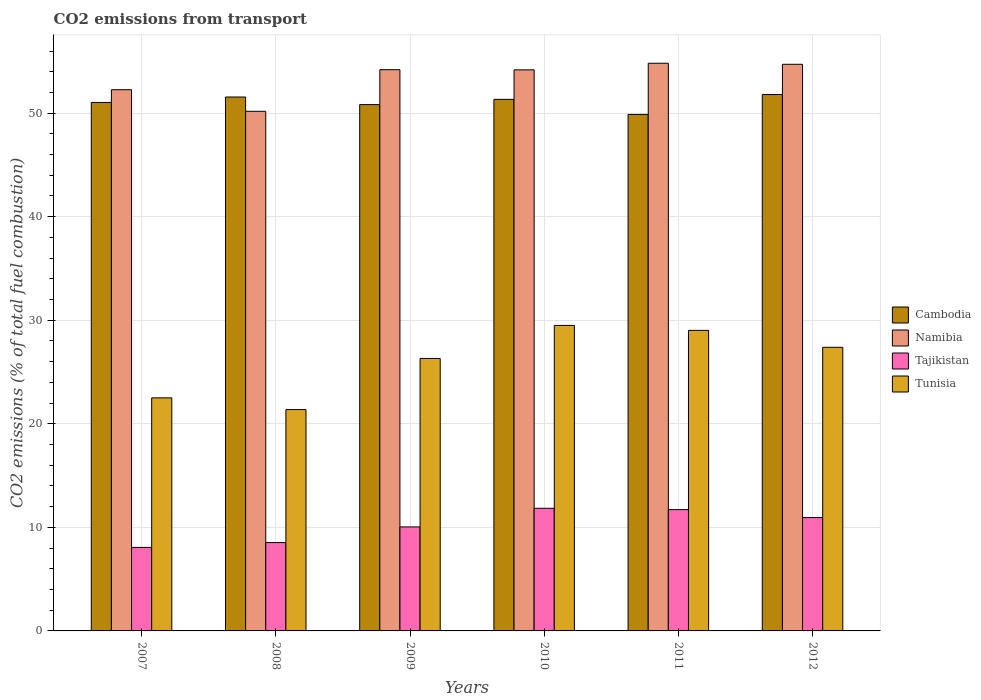How many bars are there on the 1st tick from the right?
Ensure brevity in your answer.  4. What is the label of the 4th group of bars from the left?
Offer a terse response. 2010. In how many cases, is the number of bars for a given year not equal to the number of legend labels?
Make the answer very short. 0. What is the total CO2 emitted in Tajikistan in 2007?
Offer a very short reply. 8.06. Across all years, what is the maximum total CO2 emitted in Tajikistan?
Provide a succinct answer. 11.84. Across all years, what is the minimum total CO2 emitted in Namibia?
Offer a very short reply. 50.18. In which year was the total CO2 emitted in Tunisia maximum?
Make the answer very short. 2010. In which year was the total CO2 emitted in Cambodia minimum?
Offer a very short reply. 2011. What is the total total CO2 emitted in Namibia in the graph?
Your answer should be compact. 320.35. What is the difference between the total CO2 emitted in Tajikistan in 2007 and that in 2012?
Provide a short and direct response. -2.88. What is the difference between the total CO2 emitted in Tajikistan in 2007 and the total CO2 emitted in Namibia in 2010?
Your answer should be very brief. -46.12. What is the average total CO2 emitted in Namibia per year?
Keep it short and to the point. 53.39. In the year 2012, what is the difference between the total CO2 emitted in Tunisia and total CO2 emitted in Cambodia?
Keep it short and to the point. -24.41. What is the ratio of the total CO2 emitted in Cambodia in 2007 to that in 2012?
Provide a succinct answer. 0.99. Is the total CO2 emitted in Namibia in 2007 less than that in 2008?
Your response must be concise. No. What is the difference between the highest and the second highest total CO2 emitted in Tajikistan?
Ensure brevity in your answer.  0.13. What is the difference between the highest and the lowest total CO2 emitted in Namibia?
Give a very brief answer. 4.64. In how many years, is the total CO2 emitted in Cambodia greater than the average total CO2 emitted in Cambodia taken over all years?
Your answer should be very brief. 3. Is the sum of the total CO2 emitted in Tunisia in 2009 and 2012 greater than the maximum total CO2 emitted in Namibia across all years?
Provide a short and direct response. No. Is it the case that in every year, the sum of the total CO2 emitted in Tunisia and total CO2 emitted in Cambodia is greater than the sum of total CO2 emitted in Namibia and total CO2 emitted in Tajikistan?
Offer a very short reply. No. What does the 2nd bar from the left in 2007 represents?
Your answer should be compact. Namibia. What does the 1st bar from the right in 2011 represents?
Your answer should be compact. Tunisia. How many bars are there?
Provide a succinct answer. 24. Are all the bars in the graph horizontal?
Provide a short and direct response. No. What is the difference between two consecutive major ticks on the Y-axis?
Make the answer very short. 10. Does the graph contain any zero values?
Your response must be concise. No. Does the graph contain grids?
Your response must be concise. Yes. Where does the legend appear in the graph?
Your answer should be compact. Center right. How many legend labels are there?
Your response must be concise. 4. How are the legend labels stacked?
Ensure brevity in your answer.  Vertical. What is the title of the graph?
Offer a very short reply. CO2 emissions from transport. Does "Togo" appear as one of the legend labels in the graph?
Your answer should be very brief. No. What is the label or title of the Y-axis?
Your answer should be compact. CO2 emissions (% of total fuel combustion). What is the CO2 emissions (% of total fuel combustion) in Cambodia in 2007?
Make the answer very short. 51.03. What is the CO2 emissions (% of total fuel combustion) of Namibia in 2007?
Provide a succinct answer. 52.26. What is the CO2 emissions (% of total fuel combustion) of Tajikistan in 2007?
Your answer should be compact. 8.06. What is the CO2 emissions (% of total fuel combustion) of Tunisia in 2007?
Keep it short and to the point. 22.51. What is the CO2 emissions (% of total fuel combustion) of Cambodia in 2008?
Give a very brief answer. 51.56. What is the CO2 emissions (% of total fuel combustion) of Namibia in 2008?
Make the answer very short. 50.18. What is the CO2 emissions (% of total fuel combustion) of Tajikistan in 2008?
Provide a short and direct response. 8.53. What is the CO2 emissions (% of total fuel combustion) of Tunisia in 2008?
Your response must be concise. 21.38. What is the CO2 emissions (% of total fuel combustion) in Cambodia in 2009?
Keep it short and to the point. 50.82. What is the CO2 emissions (% of total fuel combustion) of Namibia in 2009?
Your response must be concise. 54.2. What is the CO2 emissions (% of total fuel combustion) in Tajikistan in 2009?
Provide a succinct answer. 10.04. What is the CO2 emissions (% of total fuel combustion) of Tunisia in 2009?
Provide a succinct answer. 26.31. What is the CO2 emissions (% of total fuel combustion) of Cambodia in 2010?
Your response must be concise. 51.33. What is the CO2 emissions (% of total fuel combustion) of Namibia in 2010?
Provide a short and direct response. 54.18. What is the CO2 emissions (% of total fuel combustion) of Tajikistan in 2010?
Keep it short and to the point. 11.84. What is the CO2 emissions (% of total fuel combustion) in Tunisia in 2010?
Your answer should be compact. 29.5. What is the CO2 emissions (% of total fuel combustion) of Cambodia in 2011?
Your answer should be very brief. 49.88. What is the CO2 emissions (% of total fuel combustion) of Namibia in 2011?
Your answer should be compact. 54.82. What is the CO2 emissions (% of total fuel combustion) of Tajikistan in 2011?
Your answer should be very brief. 11.72. What is the CO2 emissions (% of total fuel combustion) of Tunisia in 2011?
Your answer should be compact. 29.02. What is the CO2 emissions (% of total fuel combustion) in Cambodia in 2012?
Offer a terse response. 51.8. What is the CO2 emissions (% of total fuel combustion) of Namibia in 2012?
Offer a very short reply. 54.72. What is the CO2 emissions (% of total fuel combustion) in Tajikistan in 2012?
Provide a short and direct response. 10.95. What is the CO2 emissions (% of total fuel combustion) in Tunisia in 2012?
Your answer should be very brief. 27.39. Across all years, what is the maximum CO2 emissions (% of total fuel combustion) in Cambodia?
Your answer should be compact. 51.8. Across all years, what is the maximum CO2 emissions (% of total fuel combustion) of Namibia?
Offer a terse response. 54.82. Across all years, what is the maximum CO2 emissions (% of total fuel combustion) of Tajikistan?
Offer a very short reply. 11.84. Across all years, what is the maximum CO2 emissions (% of total fuel combustion) of Tunisia?
Offer a terse response. 29.5. Across all years, what is the minimum CO2 emissions (% of total fuel combustion) in Cambodia?
Make the answer very short. 49.88. Across all years, what is the minimum CO2 emissions (% of total fuel combustion) of Namibia?
Your answer should be very brief. 50.18. Across all years, what is the minimum CO2 emissions (% of total fuel combustion) of Tajikistan?
Ensure brevity in your answer.  8.06. Across all years, what is the minimum CO2 emissions (% of total fuel combustion) in Tunisia?
Make the answer very short. 21.38. What is the total CO2 emissions (% of total fuel combustion) in Cambodia in the graph?
Make the answer very short. 306.42. What is the total CO2 emissions (% of total fuel combustion) in Namibia in the graph?
Your answer should be compact. 320.35. What is the total CO2 emissions (% of total fuel combustion) in Tajikistan in the graph?
Keep it short and to the point. 61.15. What is the total CO2 emissions (% of total fuel combustion) of Tunisia in the graph?
Keep it short and to the point. 156.1. What is the difference between the CO2 emissions (% of total fuel combustion) of Cambodia in 2007 and that in 2008?
Keep it short and to the point. -0.53. What is the difference between the CO2 emissions (% of total fuel combustion) of Namibia in 2007 and that in 2008?
Make the answer very short. 2.08. What is the difference between the CO2 emissions (% of total fuel combustion) in Tajikistan in 2007 and that in 2008?
Provide a short and direct response. -0.47. What is the difference between the CO2 emissions (% of total fuel combustion) of Tunisia in 2007 and that in 2008?
Your answer should be very brief. 1.13. What is the difference between the CO2 emissions (% of total fuel combustion) of Cambodia in 2007 and that in 2009?
Give a very brief answer. 0.21. What is the difference between the CO2 emissions (% of total fuel combustion) of Namibia in 2007 and that in 2009?
Provide a short and direct response. -1.93. What is the difference between the CO2 emissions (% of total fuel combustion) in Tajikistan in 2007 and that in 2009?
Your response must be concise. -1.98. What is the difference between the CO2 emissions (% of total fuel combustion) in Tunisia in 2007 and that in 2009?
Offer a very short reply. -3.81. What is the difference between the CO2 emissions (% of total fuel combustion) of Cambodia in 2007 and that in 2010?
Make the answer very short. -0.3. What is the difference between the CO2 emissions (% of total fuel combustion) in Namibia in 2007 and that in 2010?
Provide a succinct answer. -1.92. What is the difference between the CO2 emissions (% of total fuel combustion) in Tajikistan in 2007 and that in 2010?
Provide a short and direct response. -3.78. What is the difference between the CO2 emissions (% of total fuel combustion) in Tunisia in 2007 and that in 2010?
Provide a short and direct response. -7. What is the difference between the CO2 emissions (% of total fuel combustion) of Cambodia in 2007 and that in 2011?
Offer a terse response. 1.16. What is the difference between the CO2 emissions (% of total fuel combustion) in Namibia in 2007 and that in 2011?
Your response must be concise. -2.55. What is the difference between the CO2 emissions (% of total fuel combustion) of Tajikistan in 2007 and that in 2011?
Provide a short and direct response. -3.65. What is the difference between the CO2 emissions (% of total fuel combustion) of Tunisia in 2007 and that in 2011?
Your answer should be very brief. -6.52. What is the difference between the CO2 emissions (% of total fuel combustion) of Cambodia in 2007 and that in 2012?
Ensure brevity in your answer.  -0.77. What is the difference between the CO2 emissions (% of total fuel combustion) of Namibia in 2007 and that in 2012?
Make the answer very short. -2.45. What is the difference between the CO2 emissions (% of total fuel combustion) in Tajikistan in 2007 and that in 2012?
Keep it short and to the point. -2.88. What is the difference between the CO2 emissions (% of total fuel combustion) in Tunisia in 2007 and that in 2012?
Your response must be concise. -4.88. What is the difference between the CO2 emissions (% of total fuel combustion) of Cambodia in 2008 and that in 2009?
Your answer should be very brief. 0.73. What is the difference between the CO2 emissions (% of total fuel combustion) in Namibia in 2008 and that in 2009?
Offer a terse response. -4.02. What is the difference between the CO2 emissions (% of total fuel combustion) in Tajikistan in 2008 and that in 2009?
Offer a very short reply. -1.51. What is the difference between the CO2 emissions (% of total fuel combustion) of Tunisia in 2008 and that in 2009?
Keep it short and to the point. -4.94. What is the difference between the CO2 emissions (% of total fuel combustion) in Cambodia in 2008 and that in 2010?
Provide a succinct answer. 0.23. What is the difference between the CO2 emissions (% of total fuel combustion) of Namibia in 2008 and that in 2010?
Your response must be concise. -4. What is the difference between the CO2 emissions (% of total fuel combustion) in Tajikistan in 2008 and that in 2010?
Provide a short and direct response. -3.31. What is the difference between the CO2 emissions (% of total fuel combustion) in Tunisia in 2008 and that in 2010?
Keep it short and to the point. -8.13. What is the difference between the CO2 emissions (% of total fuel combustion) of Cambodia in 2008 and that in 2011?
Your answer should be very brief. 1.68. What is the difference between the CO2 emissions (% of total fuel combustion) of Namibia in 2008 and that in 2011?
Your response must be concise. -4.64. What is the difference between the CO2 emissions (% of total fuel combustion) in Tajikistan in 2008 and that in 2011?
Ensure brevity in your answer.  -3.18. What is the difference between the CO2 emissions (% of total fuel combustion) in Tunisia in 2008 and that in 2011?
Your answer should be very brief. -7.65. What is the difference between the CO2 emissions (% of total fuel combustion) in Cambodia in 2008 and that in 2012?
Provide a succinct answer. -0.24. What is the difference between the CO2 emissions (% of total fuel combustion) of Namibia in 2008 and that in 2012?
Provide a short and direct response. -4.54. What is the difference between the CO2 emissions (% of total fuel combustion) of Tajikistan in 2008 and that in 2012?
Keep it short and to the point. -2.42. What is the difference between the CO2 emissions (% of total fuel combustion) in Tunisia in 2008 and that in 2012?
Offer a very short reply. -6.01. What is the difference between the CO2 emissions (% of total fuel combustion) of Cambodia in 2009 and that in 2010?
Give a very brief answer. -0.51. What is the difference between the CO2 emissions (% of total fuel combustion) of Namibia in 2009 and that in 2010?
Offer a very short reply. 0.02. What is the difference between the CO2 emissions (% of total fuel combustion) in Tajikistan in 2009 and that in 2010?
Give a very brief answer. -1.8. What is the difference between the CO2 emissions (% of total fuel combustion) in Tunisia in 2009 and that in 2010?
Your answer should be very brief. -3.19. What is the difference between the CO2 emissions (% of total fuel combustion) of Cambodia in 2009 and that in 2011?
Give a very brief answer. 0.95. What is the difference between the CO2 emissions (% of total fuel combustion) in Namibia in 2009 and that in 2011?
Provide a succinct answer. -0.62. What is the difference between the CO2 emissions (% of total fuel combustion) of Tajikistan in 2009 and that in 2011?
Provide a succinct answer. -1.67. What is the difference between the CO2 emissions (% of total fuel combustion) of Tunisia in 2009 and that in 2011?
Provide a succinct answer. -2.71. What is the difference between the CO2 emissions (% of total fuel combustion) in Cambodia in 2009 and that in 2012?
Provide a short and direct response. -0.97. What is the difference between the CO2 emissions (% of total fuel combustion) in Namibia in 2009 and that in 2012?
Give a very brief answer. -0.52. What is the difference between the CO2 emissions (% of total fuel combustion) in Tajikistan in 2009 and that in 2012?
Ensure brevity in your answer.  -0.91. What is the difference between the CO2 emissions (% of total fuel combustion) of Tunisia in 2009 and that in 2012?
Ensure brevity in your answer.  -1.07. What is the difference between the CO2 emissions (% of total fuel combustion) in Cambodia in 2010 and that in 2011?
Provide a succinct answer. 1.45. What is the difference between the CO2 emissions (% of total fuel combustion) of Namibia in 2010 and that in 2011?
Offer a terse response. -0.64. What is the difference between the CO2 emissions (% of total fuel combustion) in Tajikistan in 2010 and that in 2011?
Provide a short and direct response. 0.13. What is the difference between the CO2 emissions (% of total fuel combustion) in Tunisia in 2010 and that in 2011?
Your answer should be compact. 0.48. What is the difference between the CO2 emissions (% of total fuel combustion) in Cambodia in 2010 and that in 2012?
Your response must be concise. -0.47. What is the difference between the CO2 emissions (% of total fuel combustion) of Namibia in 2010 and that in 2012?
Provide a succinct answer. -0.54. What is the difference between the CO2 emissions (% of total fuel combustion) in Tajikistan in 2010 and that in 2012?
Keep it short and to the point. 0.89. What is the difference between the CO2 emissions (% of total fuel combustion) of Tunisia in 2010 and that in 2012?
Your answer should be very brief. 2.11. What is the difference between the CO2 emissions (% of total fuel combustion) of Cambodia in 2011 and that in 2012?
Your response must be concise. -1.92. What is the difference between the CO2 emissions (% of total fuel combustion) of Namibia in 2011 and that in 2012?
Offer a terse response. 0.1. What is the difference between the CO2 emissions (% of total fuel combustion) of Tajikistan in 2011 and that in 2012?
Make the answer very short. 0.77. What is the difference between the CO2 emissions (% of total fuel combustion) in Tunisia in 2011 and that in 2012?
Offer a terse response. 1.63. What is the difference between the CO2 emissions (% of total fuel combustion) of Cambodia in 2007 and the CO2 emissions (% of total fuel combustion) of Namibia in 2008?
Your response must be concise. 0.85. What is the difference between the CO2 emissions (% of total fuel combustion) of Cambodia in 2007 and the CO2 emissions (% of total fuel combustion) of Tajikistan in 2008?
Make the answer very short. 42.5. What is the difference between the CO2 emissions (% of total fuel combustion) in Cambodia in 2007 and the CO2 emissions (% of total fuel combustion) in Tunisia in 2008?
Ensure brevity in your answer.  29.66. What is the difference between the CO2 emissions (% of total fuel combustion) of Namibia in 2007 and the CO2 emissions (% of total fuel combustion) of Tajikistan in 2008?
Your response must be concise. 43.73. What is the difference between the CO2 emissions (% of total fuel combustion) in Namibia in 2007 and the CO2 emissions (% of total fuel combustion) in Tunisia in 2008?
Your answer should be very brief. 30.89. What is the difference between the CO2 emissions (% of total fuel combustion) of Tajikistan in 2007 and the CO2 emissions (% of total fuel combustion) of Tunisia in 2008?
Offer a very short reply. -13.31. What is the difference between the CO2 emissions (% of total fuel combustion) of Cambodia in 2007 and the CO2 emissions (% of total fuel combustion) of Namibia in 2009?
Your answer should be compact. -3.16. What is the difference between the CO2 emissions (% of total fuel combustion) in Cambodia in 2007 and the CO2 emissions (% of total fuel combustion) in Tajikistan in 2009?
Provide a short and direct response. 40.99. What is the difference between the CO2 emissions (% of total fuel combustion) in Cambodia in 2007 and the CO2 emissions (% of total fuel combustion) in Tunisia in 2009?
Offer a very short reply. 24.72. What is the difference between the CO2 emissions (% of total fuel combustion) in Namibia in 2007 and the CO2 emissions (% of total fuel combustion) in Tajikistan in 2009?
Your answer should be compact. 42.22. What is the difference between the CO2 emissions (% of total fuel combustion) of Namibia in 2007 and the CO2 emissions (% of total fuel combustion) of Tunisia in 2009?
Provide a short and direct response. 25.95. What is the difference between the CO2 emissions (% of total fuel combustion) of Tajikistan in 2007 and the CO2 emissions (% of total fuel combustion) of Tunisia in 2009?
Provide a succinct answer. -18.25. What is the difference between the CO2 emissions (% of total fuel combustion) in Cambodia in 2007 and the CO2 emissions (% of total fuel combustion) in Namibia in 2010?
Offer a terse response. -3.15. What is the difference between the CO2 emissions (% of total fuel combustion) in Cambodia in 2007 and the CO2 emissions (% of total fuel combustion) in Tajikistan in 2010?
Keep it short and to the point. 39.19. What is the difference between the CO2 emissions (% of total fuel combustion) in Cambodia in 2007 and the CO2 emissions (% of total fuel combustion) in Tunisia in 2010?
Give a very brief answer. 21.53. What is the difference between the CO2 emissions (% of total fuel combustion) of Namibia in 2007 and the CO2 emissions (% of total fuel combustion) of Tajikistan in 2010?
Ensure brevity in your answer.  40.42. What is the difference between the CO2 emissions (% of total fuel combustion) of Namibia in 2007 and the CO2 emissions (% of total fuel combustion) of Tunisia in 2010?
Make the answer very short. 22.76. What is the difference between the CO2 emissions (% of total fuel combustion) in Tajikistan in 2007 and the CO2 emissions (% of total fuel combustion) in Tunisia in 2010?
Keep it short and to the point. -21.44. What is the difference between the CO2 emissions (% of total fuel combustion) of Cambodia in 2007 and the CO2 emissions (% of total fuel combustion) of Namibia in 2011?
Provide a short and direct response. -3.78. What is the difference between the CO2 emissions (% of total fuel combustion) in Cambodia in 2007 and the CO2 emissions (% of total fuel combustion) in Tajikistan in 2011?
Keep it short and to the point. 39.32. What is the difference between the CO2 emissions (% of total fuel combustion) in Cambodia in 2007 and the CO2 emissions (% of total fuel combustion) in Tunisia in 2011?
Offer a very short reply. 22.01. What is the difference between the CO2 emissions (% of total fuel combustion) in Namibia in 2007 and the CO2 emissions (% of total fuel combustion) in Tajikistan in 2011?
Ensure brevity in your answer.  40.55. What is the difference between the CO2 emissions (% of total fuel combustion) of Namibia in 2007 and the CO2 emissions (% of total fuel combustion) of Tunisia in 2011?
Provide a short and direct response. 23.24. What is the difference between the CO2 emissions (% of total fuel combustion) in Tajikistan in 2007 and the CO2 emissions (% of total fuel combustion) in Tunisia in 2011?
Ensure brevity in your answer.  -20.96. What is the difference between the CO2 emissions (% of total fuel combustion) in Cambodia in 2007 and the CO2 emissions (% of total fuel combustion) in Namibia in 2012?
Ensure brevity in your answer.  -3.68. What is the difference between the CO2 emissions (% of total fuel combustion) in Cambodia in 2007 and the CO2 emissions (% of total fuel combustion) in Tajikistan in 2012?
Your answer should be very brief. 40.08. What is the difference between the CO2 emissions (% of total fuel combustion) in Cambodia in 2007 and the CO2 emissions (% of total fuel combustion) in Tunisia in 2012?
Your answer should be compact. 23.65. What is the difference between the CO2 emissions (% of total fuel combustion) in Namibia in 2007 and the CO2 emissions (% of total fuel combustion) in Tajikistan in 2012?
Your response must be concise. 41.31. What is the difference between the CO2 emissions (% of total fuel combustion) of Namibia in 2007 and the CO2 emissions (% of total fuel combustion) of Tunisia in 2012?
Give a very brief answer. 24.88. What is the difference between the CO2 emissions (% of total fuel combustion) in Tajikistan in 2007 and the CO2 emissions (% of total fuel combustion) in Tunisia in 2012?
Your response must be concise. -19.32. What is the difference between the CO2 emissions (% of total fuel combustion) of Cambodia in 2008 and the CO2 emissions (% of total fuel combustion) of Namibia in 2009?
Make the answer very short. -2.64. What is the difference between the CO2 emissions (% of total fuel combustion) in Cambodia in 2008 and the CO2 emissions (% of total fuel combustion) in Tajikistan in 2009?
Offer a very short reply. 41.51. What is the difference between the CO2 emissions (% of total fuel combustion) in Cambodia in 2008 and the CO2 emissions (% of total fuel combustion) in Tunisia in 2009?
Your response must be concise. 25.24. What is the difference between the CO2 emissions (% of total fuel combustion) of Namibia in 2008 and the CO2 emissions (% of total fuel combustion) of Tajikistan in 2009?
Offer a very short reply. 40.14. What is the difference between the CO2 emissions (% of total fuel combustion) of Namibia in 2008 and the CO2 emissions (% of total fuel combustion) of Tunisia in 2009?
Ensure brevity in your answer.  23.87. What is the difference between the CO2 emissions (% of total fuel combustion) of Tajikistan in 2008 and the CO2 emissions (% of total fuel combustion) of Tunisia in 2009?
Offer a terse response. -17.78. What is the difference between the CO2 emissions (% of total fuel combustion) of Cambodia in 2008 and the CO2 emissions (% of total fuel combustion) of Namibia in 2010?
Offer a very short reply. -2.62. What is the difference between the CO2 emissions (% of total fuel combustion) in Cambodia in 2008 and the CO2 emissions (% of total fuel combustion) in Tajikistan in 2010?
Your answer should be very brief. 39.72. What is the difference between the CO2 emissions (% of total fuel combustion) of Cambodia in 2008 and the CO2 emissions (% of total fuel combustion) of Tunisia in 2010?
Offer a very short reply. 22.06. What is the difference between the CO2 emissions (% of total fuel combustion) of Namibia in 2008 and the CO2 emissions (% of total fuel combustion) of Tajikistan in 2010?
Your answer should be compact. 38.34. What is the difference between the CO2 emissions (% of total fuel combustion) of Namibia in 2008 and the CO2 emissions (% of total fuel combustion) of Tunisia in 2010?
Provide a succinct answer. 20.68. What is the difference between the CO2 emissions (% of total fuel combustion) of Tajikistan in 2008 and the CO2 emissions (% of total fuel combustion) of Tunisia in 2010?
Your answer should be compact. -20.97. What is the difference between the CO2 emissions (% of total fuel combustion) of Cambodia in 2008 and the CO2 emissions (% of total fuel combustion) of Namibia in 2011?
Give a very brief answer. -3.26. What is the difference between the CO2 emissions (% of total fuel combustion) in Cambodia in 2008 and the CO2 emissions (% of total fuel combustion) in Tajikistan in 2011?
Make the answer very short. 39.84. What is the difference between the CO2 emissions (% of total fuel combustion) of Cambodia in 2008 and the CO2 emissions (% of total fuel combustion) of Tunisia in 2011?
Ensure brevity in your answer.  22.54. What is the difference between the CO2 emissions (% of total fuel combustion) in Namibia in 2008 and the CO2 emissions (% of total fuel combustion) in Tajikistan in 2011?
Your answer should be very brief. 38.46. What is the difference between the CO2 emissions (% of total fuel combustion) of Namibia in 2008 and the CO2 emissions (% of total fuel combustion) of Tunisia in 2011?
Ensure brevity in your answer.  21.16. What is the difference between the CO2 emissions (% of total fuel combustion) in Tajikistan in 2008 and the CO2 emissions (% of total fuel combustion) in Tunisia in 2011?
Provide a succinct answer. -20.49. What is the difference between the CO2 emissions (% of total fuel combustion) in Cambodia in 2008 and the CO2 emissions (% of total fuel combustion) in Namibia in 2012?
Make the answer very short. -3.16. What is the difference between the CO2 emissions (% of total fuel combustion) of Cambodia in 2008 and the CO2 emissions (% of total fuel combustion) of Tajikistan in 2012?
Your response must be concise. 40.61. What is the difference between the CO2 emissions (% of total fuel combustion) of Cambodia in 2008 and the CO2 emissions (% of total fuel combustion) of Tunisia in 2012?
Offer a terse response. 24.17. What is the difference between the CO2 emissions (% of total fuel combustion) of Namibia in 2008 and the CO2 emissions (% of total fuel combustion) of Tajikistan in 2012?
Make the answer very short. 39.23. What is the difference between the CO2 emissions (% of total fuel combustion) of Namibia in 2008 and the CO2 emissions (% of total fuel combustion) of Tunisia in 2012?
Your answer should be very brief. 22.79. What is the difference between the CO2 emissions (% of total fuel combustion) of Tajikistan in 2008 and the CO2 emissions (% of total fuel combustion) of Tunisia in 2012?
Offer a very short reply. -18.85. What is the difference between the CO2 emissions (% of total fuel combustion) in Cambodia in 2009 and the CO2 emissions (% of total fuel combustion) in Namibia in 2010?
Your answer should be very brief. -3.36. What is the difference between the CO2 emissions (% of total fuel combustion) of Cambodia in 2009 and the CO2 emissions (% of total fuel combustion) of Tajikistan in 2010?
Ensure brevity in your answer.  38.98. What is the difference between the CO2 emissions (% of total fuel combustion) in Cambodia in 2009 and the CO2 emissions (% of total fuel combustion) in Tunisia in 2010?
Offer a very short reply. 21.32. What is the difference between the CO2 emissions (% of total fuel combustion) in Namibia in 2009 and the CO2 emissions (% of total fuel combustion) in Tajikistan in 2010?
Offer a very short reply. 42.35. What is the difference between the CO2 emissions (% of total fuel combustion) in Namibia in 2009 and the CO2 emissions (% of total fuel combustion) in Tunisia in 2010?
Ensure brevity in your answer.  24.69. What is the difference between the CO2 emissions (% of total fuel combustion) in Tajikistan in 2009 and the CO2 emissions (% of total fuel combustion) in Tunisia in 2010?
Keep it short and to the point. -19.46. What is the difference between the CO2 emissions (% of total fuel combustion) in Cambodia in 2009 and the CO2 emissions (% of total fuel combustion) in Namibia in 2011?
Provide a short and direct response. -3.99. What is the difference between the CO2 emissions (% of total fuel combustion) in Cambodia in 2009 and the CO2 emissions (% of total fuel combustion) in Tajikistan in 2011?
Make the answer very short. 39.11. What is the difference between the CO2 emissions (% of total fuel combustion) in Cambodia in 2009 and the CO2 emissions (% of total fuel combustion) in Tunisia in 2011?
Provide a short and direct response. 21.8. What is the difference between the CO2 emissions (% of total fuel combustion) in Namibia in 2009 and the CO2 emissions (% of total fuel combustion) in Tajikistan in 2011?
Make the answer very short. 42.48. What is the difference between the CO2 emissions (% of total fuel combustion) of Namibia in 2009 and the CO2 emissions (% of total fuel combustion) of Tunisia in 2011?
Keep it short and to the point. 25.17. What is the difference between the CO2 emissions (% of total fuel combustion) in Tajikistan in 2009 and the CO2 emissions (% of total fuel combustion) in Tunisia in 2011?
Your answer should be very brief. -18.98. What is the difference between the CO2 emissions (% of total fuel combustion) of Cambodia in 2009 and the CO2 emissions (% of total fuel combustion) of Namibia in 2012?
Provide a short and direct response. -3.89. What is the difference between the CO2 emissions (% of total fuel combustion) of Cambodia in 2009 and the CO2 emissions (% of total fuel combustion) of Tajikistan in 2012?
Make the answer very short. 39.88. What is the difference between the CO2 emissions (% of total fuel combustion) of Cambodia in 2009 and the CO2 emissions (% of total fuel combustion) of Tunisia in 2012?
Make the answer very short. 23.44. What is the difference between the CO2 emissions (% of total fuel combustion) in Namibia in 2009 and the CO2 emissions (% of total fuel combustion) in Tajikistan in 2012?
Keep it short and to the point. 43.25. What is the difference between the CO2 emissions (% of total fuel combustion) in Namibia in 2009 and the CO2 emissions (% of total fuel combustion) in Tunisia in 2012?
Offer a terse response. 26.81. What is the difference between the CO2 emissions (% of total fuel combustion) in Tajikistan in 2009 and the CO2 emissions (% of total fuel combustion) in Tunisia in 2012?
Ensure brevity in your answer.  -17.34. What is the difference between the CO2 emissions (% of total fuel combustion) in Cambodia in 2010 and the CO2 emissions (% of total fuel combustion) in Namibia in 2011?
Your response must be concise. -3.49. What is the difference between the CO2 emissions (% of total fuel combustion) in Cambodia in 2010 and the CO2 emissions (% of total fuel combustion) in Tajikistan in 2011?
Offer a very short reply. 39.61. What is the difference between the CO2 emissions (% of total fuel combustion) in Cambodia in 2010 and the CO2 emissions (% of total fuel combustion) in Tunisia in 2011?
Ensure brevity in your answer.  22.31. What is the difference between the CO2 emissions (% of total fuel combustion) of Namibia in 2010 and the CO2 emissions (% of total fuel combustion) of Tajikistan in 2011?
Keep it short and to the point. 42.47. What is the difference between the CO2 emissions (% of total fuel combustion) of Namibia in 2010 and the CO2 emissions (% of total fuel combustion) of Tunisia in 2011?
Provide a succinct answer. 25.16. What is the difference between the CO2 emissions (% of total fuel combustion) in Tajikistan in 2010 and the CO2 emissions (% of total fuel combustion) in Tunisia in 2011?
Make the answer very short. -17.18. What is the difference between the CO2 emissions (% of total fuel combustion) in Cambodia in 2010 and the CO2 emissions (% of total fuel combustion) in Namibia in 2012?
Make the answer very short. -3.39. What is the difference between the CO2 emissions (% of total fuel combustion) in Cambodia in 2010 and the CO2 emissions (% of total fuel combustion) in Tajikistan in 2012?
Make the answer very short. 40.38. What is the difference between the CO2 emissions (% of total fuel combustion) of Cambodia in 2010 and the CO2 emissions (% of total fuel combustion) of Tunisia in 2012?
Provide a succinct answer. 23.94. What is the difference between the CO2 emissions (% of total fuel combustion) of Namibia in 2010 and the CO2 emissions (% of total fuel combustion) of Tajikistan in 2012?
Provide a short and direct response. 43.23. What is the difference between the CO2 emissions (% of total fuel combustion) in Namibia in 2010 and the CO2 emissions (% of total fuel combustion) in Tunisia in 2012?
Give a very brief answer. 26.79. What is the difference between the CO2 emissions (% of total fuel combustion) in Tajikistan in 2010 and the CO2 emissions (% of total fuel combustion) in Tunisia in 2012?
Your answer should be very brief. -15.54. What is the difference between the CO2 emissions (% of total fuel combustion) in Cambodia in 2011 and the CO2 emissions (% of total fuel combustion) in Namibia in 2012?
Your answer should be compact. -4.84. What is the difference between the CO2 emissions (% of total fuel combustion) of Cambodia in 2011 and the CO2 emissions (% of total fuel combustion) of Tajikistan in 2012?
Your answer should be very brief. 38.93. What is the difference between the CO2 emissions (% of total fuel combustion) in Cambodia in 2011 and the CO2 emissions (% of total fuel combustion) in Tunisia in 2012?
Give a very brief answer. 22.49. What is the difference between the CO2 emissions (% of total fuel combustion) of Namibia in 2011 and the CO2 emissions (% of total fuel combustion) of Tajikistan in 2012?
Your answer should be compact. 43.87. What is the difference between the CO2 emissions (% of total fuel combustion) in Namibia in 2011 and the CO2 emissions (% of total fuel combustion) in Tunisia in 2012?
Offer a terse response. 27.43. What is the difference between the CO2 emissions (% of total fuel combustion) in Tajikistan in 2011 and the CO2 emissions (% of total fuel combustion) in Tunisia in 2012?
Give a very brief answer. -15.67. What is the average CO2 emissions (% of total fuel combustion) of Cambodia per year?
Offer a terse response. 51.07. What is the average CO2 emissions (% of total fuel combustion) of Namibia per year?
Your response must be concise. 53.39. What is the average CO2 emissions (% of total fuel combustion) of Tajikistan per year?
Offer a terse response. 10.19. What is the average CO2 emissions (% of total fuel combustion) of Tunisia per year?
Give a very brief answer. 26.02. In the year 2007, what is the difference between the CO2 emissions (% of total fuel combustion) of Cambodia and CO2 emissions (% of total fuel combustion) of Namibia?
Your response must be concise. -1.23. In the year 2007, what is the difference between the CO2 emissions (% of total fuel combustion) of Cambodia and CO2 emissions (% of total fuel combustion) of Tajikistan?
Give a very brief answer. 42.97. In the year 2007, what is the difference between the CO2 emissions (% of total fuel combustion) of Cambodia and CO2 emissions (% of total fuel combustion) of Tunisia?
Your answer should be compact. 28.53. In the year 2007, what is the difference between the CO2 emissions (% of total fuel combustion) of Namibia and CO2 emissions (% of total fuel combustion) of Tajikistan?
Make the answer very short. 44.2. In the year 2007, what is the difference between the CO2 emissions (% of total fuel combustion) of Namibia and CO2 emissions (% of total fuel combustion) of Tunisia?
Keep it short and to the point. 29.76. In the year 2007, what is the difference between the CO2 emissions (% of total fuel combustion) in Tajikistan and CO2 emissions (% of total fuel combustion) in Tunisia?
Offer a terse response. -14.44. In the year 2008, what is the difference between the CO2 emissions (% of total fuel combustion) in Cambodia and CO2 emissions (% of total fuel combustion) in Namibia?
Provide a succinct answer. 1.38. In the year 2008, what is the difference between the CO2 emissions (% of total fuel combustion) of Cambodia and CO2 emissions (% of total fuel combustion) of Tajikistan?
Ensure brevity in your answer.  43.03. In the year 2008, what is the difference between the CO2 emissions (% of total fuel combustion) in Cambodia and CO2 emissions (% of total fuel combustion) in Tunisia?
Your answer should be compact. 30.18. In the year 2008, what is the difference between the CO2 emissions (% of total fuel combustion) in Namibia and CO2 emissions (% of total fuel combustion) in Tajikistan?
Your response must be concise. 41.65. In the year 2008, what is the difference between the CO2 emissions (% of total fuel combustion) of Namibia and CO2 emissions (% of total fuel combustion) of Tunisia?
Your answer should be very brief. 28.8. In the year 2008, what is the difference between the CO2 emissions (% of total fuel combustion) in Tajikistan and CO2 emissions (% of total fuel combustion) in Tunisia?
Provide a succinct answer. -12.84. In the year 2009, what is the difference between the CO2 emissions (% of total fuel combustion) in Cambodia and CO2 emissions (% of total fuel combustion) in Namibia?
Ensure brevity in your answer.  -3.37. In the year 2009, what is the difference between the CO2 emissions (% of total fuel combustion) in Cambodia and CO2 emissions (% of total fuel combustion) in Tajikistan?
Provide a short and direct response. 40.78. In the year 2009, what is the difference between the CO2 emissions (% of total fuel combustion) in Cambodia and CO2 emissions (% of total fuel combustion) in Tunisia?
Ensure brevity in your answer.  24.51. In the year 2009, what is the difference between the CO2 emissions (% of total fuel combustion) in Namibia and CO2 emissions (% of total fuel combustion) in Tajikistan?
Your response must be concise. 44.15. In the year 2009, what is the difference between the CO2 emissions (% of total fuel combustion) of Namibia and CO2 emissions (% of total fuel combustion) of Tunisia?
Make the answer very short. 27.88. In the year 2009, what is the difference between the CO2 emissions (% of total fuel combustion) in Tajikistan and CO2 emissions (% of total fuel combustion) in Tunisia?
Make the answer very short. -16.27. In the year 2010, what is the difference between the CO2 emissions (% of total fuel combustion) of Cambodia and CO2 emissions (% of total fuel combustion) of Namibia?
Ensure brevity in your answer.  -2.85. In the year 2010, what is the difference between the CO2 emissions (% of total fuel combustion) in Cambodia and CO2 emissions (% of total fuel combustion) in Tajikistan?
Provide a succinct answer. 39.49. In the year 2010, what is the difference between the CO2 emissions (% of total fuel combustion) in Cambodia and CO2 emissions (% of total fuel combustion) in Tunisia?
Give a very brief answer. 21.83. In the year 2010, what is the difference between the CO2 emissions (% of total fuel combustion) of Namibia and CO2 emissions (% of total fuel combustion) of Tajikistan?
Offer a very short reply. 42.34. In the year 2010, what is the difference between the CO2 emissions (% of total fuel combustion) in Namibia and CO2 emissions (% of total fuel combustion) in Tunisia?
Your answer should be compact. 24.68. In the year 2010, what is the difference between the CO2 emissions (% of total fuel combustion) in Tajikistan and CO2 emissions (% of total fuel combustion) in Tunisia?
Offer a very short reply. -17.66. In the year 2011, what is the difference between the CO2 emissions (% of total fuel combustion) in Cambodia and CO2 emissions (% of total fuel combustion) in Namibia?
Provide a short and direct response. -4.94. In the year 2011, what is the difference between the CO2 emissions (% of total fuel combustion) of Cambodia and CO2 emissions (% of total fuel combustion) of Tajikistan?
Your answer should be compact. 38.16. In the year 2011, what is the difference between the CO2 emissions (% of total fuel combustion) in Cambodia and CO2 emissions (% of total fuel combustion) in Tunisia?
Provide a succinct answer. 20.85. In the year 2011, what is the difference between the CO2 emissions (% of total fuel combustion) in Namibia and CO2 emissions (% of total fuel combustion) in Tajikistan?
Your answer should be compact. 43.1. In the year 2011, what is the difference between the CO2 emissions (% of total fuel combustion) in Namibia and CO2 emissions (% of total fuel combustion) in Tunisia?
Provide a short and direct response. 25.8. In the year 2011, what is the difference between the CO2 emissions (% of total fuel combustion) in Tajikistan and CO2 emissions (% of total fuel combustion) in Tunisia?
Ensure brevity in your answer.  -17.31. In the year 2012, what is the difference between the CO2 emissions (% of total fuel combustion) of Cambodia and CO2 emissions (% of total fuel combustion) of Namibia?
Your response must be concise. -2.92. In the year 2012, what is the difference between the CO2 emissions (% of total fuel combustion) in Cambodia and CO2 emissions (% of total fuel combustion) in Tajikistan?
Keep it short and to the point. 40.85. In the year 2012, what is the difference between the CO2 emissions (% of total fuel combustion) in Cambodia and CO2 emissions (% of total fuel combustion) in Tunisia?
Give a very brief answer. 24.41. In the year 2012, what is the difference between the CO2 emissions (% of total fuel combustion) in Namibia and CO2 emissions (% of total fuel combustion) in Tajikistan?
Your response must be concise. 43.77. In the year 2012, what is the difference between the CO2 emissions (% of total fuel combustion) of Namibia and CO2 emissions (% of total fuel combustion) of Tunisia?
Provide a short and direct response. 27.33. In the year 2012, what is the difference between the CO2 emissions (% of total fuel combustion) of Tajikistan and CO2 emissions (% of total fuel combustion) of Tunisia?
Offer a very short reply. -16.44. What is the ratio of the CO2 emissions (% of total fuel combustion) in Cambodia in 2007 to that in 2008?
Ensure brevity in your answer.  0.99. What is the ratio of the CO2 emissions (% of total fuel combustion) of Namibia in 2007 to that in 2008?
Offer a very short reply. 1.04. What is the ratio of the CO2 emissions (% of total fuel combustion) of Tajikistan in 2007 to that in 2008?
Provide a short and direct response. 0.95. What is the ratio of the CO2 emissions (% of total fuel combustion) in Tunisia in 2007 to that in 2008?
Provide a short and direct response. 1.05. What is the ratio of the CO2 emissions (% of total fuel combustion) in Cambodia in 2007 to that in 2009?
Your response must be concise. 1. What is the ratio of the CO2 emissions (% of total fuel combustion) of Namibia in 2007 to that in 2009?
Offer a very short reply. 0.96. What is the ratio of the CO2 emissions (% of total fuel combustion) of Tajikistan in 2007 to that in 2009?
Make the answer very short. 0.8. What is the ratio of the CO2 emissions (% of total fuel combustion) in Tunisia in 2007 to that in 2009?
Offer a very short reply. 0.86. What is the ratio of the CO2 emissions (% of total fuel combustion) in Namibia in 2007 to that in 2010?
Your answer should be compact. 0.96. What is the ratio of the CO2 emissions (% of total fuel combustion) in Tajikistan in 2007 to that in 2010?
Ensure brevity in your answer.  0.68. What is the ratio of the CO2 emissions (% of total fuel combustion) of Tunisia in 2007 to that in 2010?
Ensure brevity in your answer.  0.76. What is the ratio of the CO2 emissions (% of total fuel combustion) of Cambodia in 2007 to that in 2011?
Provide a succinct answer. 1.02. What is the ratio of the CO2 emissions (% of total fuel combustion) of Namibia in 2007 to that in 2011?
Your answer should be compact. 0.95. What is the ratio of the CO2 emissions (% of total fuel combustion) of Tajikistan in 2007 to that in 2011?
Keep it short and to the point. 0.69. What is the ratio of the CO2 emissions (% of total fuel combustion) in Tunisia in 2007 to that in 2011?
Your answer should be compact. 0.78. What is the ratio of the CO2 emissions (% of total fuel combustion) of Cambodia in 2007 to that in 2012?
Provide a succinct answer. 0.99. What is the ratio of the CO2 emissions (% of total fuel combustion) in Namibia in 2007 to that in 2012?
Your answer should be very brief. 0.96. What is the ratio of the CO2 emissions (% of total fuel combustion) in Tajikistan in 2007 to that in 2012?
Ensure brevity in your answer.  0.74. What is the ratio of the CO2 emissions (% of total fuel combustion) in Tunisia in 2007 to that in 2012?
Ensure brevity in your answer.  0.82. What is the ratio of the CO2 emissions (% of total fuel combustion) in Cambodia in 2008 to that in 2009?
Make the answer very short. 1.01. What is the ratio of the CO2 emissions (% of total fuel combustion) in Namibia in 2008 to that in 2009?
Your response must be concise. 0.93. What is the ratio of the CO2 emissions (% of total fuel combustion) in Tajikistan in 2008 to that in 2009?
Your response must be concise. 0.85. What is the ratio of the CO2 emissions (% of total fuel combustion) of Tunisia in 2008 to that in 2009?
Your answer should be very brief. 0.81. What is the ratio of the CO2 emissions (% of total fuel combustion) of Namibia in 2008 to that in 2010?
Provide a short and direct response. 0.93. What is the ratio of the CO2 emissions (% of total fuel combustion) in Tajikistan in 2008 to that in 2010?
Give a very brief answer. 0.72. What is the ratio of the CO2 emissions (% of total fuel combustion) of Tunisia in 2008 to that in 2010?
Give a very brief answer. 0.72. What is the ratio of the CO2 emissions (% of total fuel combustion) of Cambodia in 2008 to that in 2011?
Provide a succinct answer. 1.03. What is the ratio of the CO2 emissions (% of total fuel combustion) in Namibia in 2008 to that in 2011?
Offer a terse response. 0.92. What is the ratio of the CO2 emissions (% of total fuel combustion) of Tajikistan in 2008 to that in 2011?
Give a very brief answer. 0.73. What is the ratio of the CO2 emissions (% of total fuel combustion) of Tunisia in 2008 to that in 2011?
Provide a succinct answer. 0.74. What is the ratio of the CO2 emissions (% of total fuel combustion) of Cambodia in 2008 to that in 2012?
Make the answer very short. 1. What is the ratio of the CO2 emissions (% of total fuel combustion) of Namibia in 2008 to that in 2012?
Offer a very short reply. 0.92. What is the ratio of the CO2 emissions (% of total fuel combustion) in Tajikistan in 2008 to that in 2012?
Offer a very short reply. 0.78. What is the ratio of the CO2 emissions (% of total fuel combustion) in Tunisia in 2008 to that in 2012?
Your answer should be very brief. 0.78. What is the ratio of the CO2 emissions (% of total fuel combustion) in Cambodia in 2009 to that in 2010?
Keep it short and to the point. 0.99. What is the ratio of the CO2 emissions (% of total fuel combustion) of Namibia in 2009 to that in 2010?
Your answer should be very brief. 1. What is the ratio of the CO2 emissions (% of total fuel combustion) of Tajikistan in 2009 to that in 2010?
Your response must be concise. 0.85. What is the ratio of the CO2 emissions (% of total fuel combustion) in Tunisia in 2009 to that in 2010?
Give a very brief answer. 0.89. What is the ratio of the CO2 emissions (% of total fuel combustion) of Namibia in 2009 to that in 2011?
Offer a terse response. 0.99. What is the ratio of the CO2 emissions (% of total fuel combustion) of Tajikistan in 2009 to that in 2011?
Provide a short and direct response. 0.86. What is the ratio of the CO2 emissions (% of total fuel combustion) in Tunisia in 2009 to that in 2011?
Offer a terse response. 0.91. What is the ratio of the CO2 emissions (% of total fuel combustion) in Cambodia in 2009 to that in 2012?
Offer a very short reply. 0.98. What is the ratio of the CO2 emissions (% of total fuel combustion) in Tajikistan in 2009 to that in 2012?
Provide a short and direct response. 0.92. What is the ratio of the CO2 emissions (% of total fuel combustion) in Tunisia in 2009 to that in 2012?
Make the answer very short. 0.96. What is the ratio of the CO2 emissions (% of total fuel combustion) of Cambodia in 2010 to that in 2011?
Keep it short and to the point. 1.03. What is the ratio of the CO2 emissions (% of total fuel combustion) in Namibia in 2010 to that in 2011?
Keep it short and to the point. 0.99. What is the ratio of the CO2 emissions (% of total fuel combustion) in Tajikistan in 2010 to that in 2011?
Make the answer very short. 1.01. What is the ratio of the CO2 emissions (% of total fuel combustion) in Tunisia in 2010 to that in 2011?
Offer a terse response. 1.02. What is the ratio of the CO2 emissions (% of total fuel combustion) in Cambodia in 2010 to that in 2012?
Make the answer very short. 0.99. What is the ratio of the CO2 emissions (% of total fuel combustion) of Namibia in 2010 to that in 2012?
Your response must be concise. 0.99. What is the ratio of the CO2 emissions (% of total fuel combustion) in Tajikistan in 2010 to that in 2012?
Give a very brief answer. 1.08. What is the ratio of the CO2 emissions (% of total fuel combustion) in Tunisia in 2010 to that in 2012?
Your response must be concise. 1.08. What is the ratio of the CO2 emissions (% of total fuel combustion) of Cambodia in 2011 to that in 2012?
Offer a terse response. 0.96. What is the ratio of the CO2 emissions (% of total fuel combustion) in Tajikistan in 2011 to that in 2012?
Provide a succinct answer. 1.07. What is the ratio of the CO2 emissions (% of total fuel combustion) in Tunisia in 2011 to that in 2012?
Offer a terse response. 1.06. What is the difference between the highest and the second highest CO2 emissions (% of total fuel combustion) in Cambodia?
Give a very brief answer. 0.24. What is the difference between the highest and the second highest CO2 emissions (% of total fuel combustion) of Namibia?
Give a very brief answer. 0.1. What is the difference between the highest and the second highest CO2 emissions (% of total fuel combustion) of Tajikistan?
Provide a short and direct response. 0.13. What is the difference between the highest and the second highest CO2 emissions (% of total fuel combustion) of Tunisia?
Ensure brevity in your answer.  0.48. What is the difference between the highest and the lowest CO2 emissions (% of total fuel combustion) of Cambodia?
Make the answer very short. 1.92. What is the difference between the highest and the lowest CO2 emissions (% of total fuel combustion) of Namibia?
Your response must be concise. 4.64. What is the difference between the highest and the lowest CO2 emissions (% of total fuel combustion) of Tajikistan?
Provide a succinct answer. 3.78. What is the difference between the highest and the lowest CO2 emissions (% of total fuel combustion) of Tunisia?
Your answer should be very brief. 8.13. 